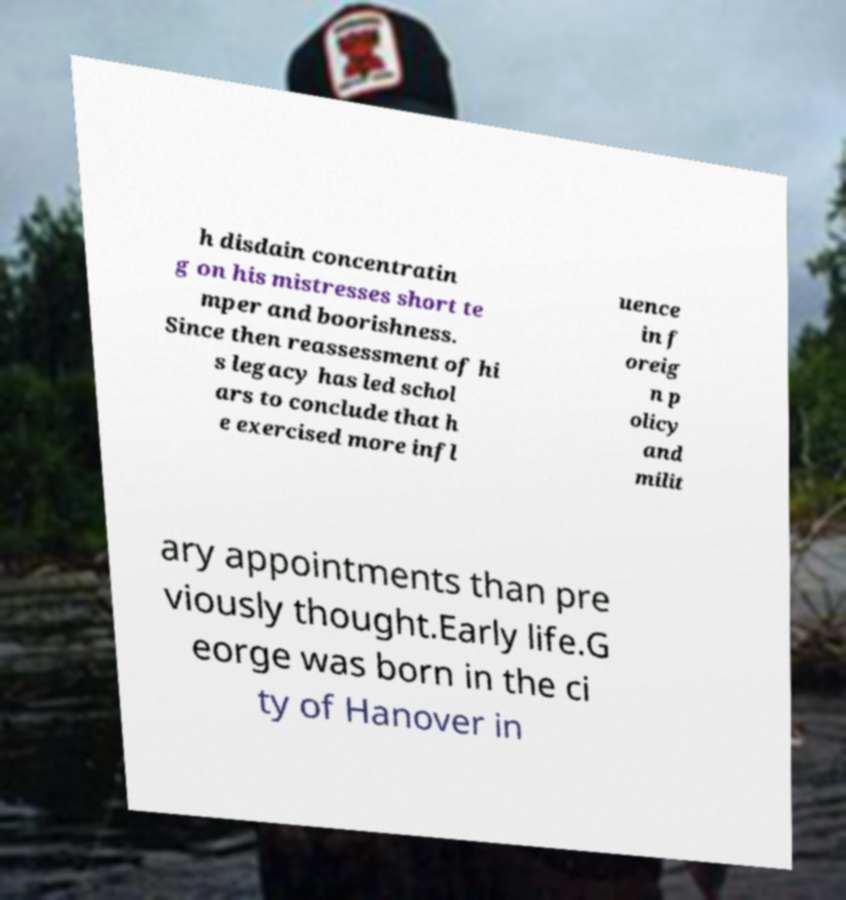Can you accurately transcribe the text from the provided image for me? h disdain concentratin g on his mistresses short te mper and boorishness. Since then reassessment of hi s legacy has led schol ars to conclude that h e exercised more infl uence in f oreig n p olicy and milit ary appointments than pre viously thought.Early life.G eorge was born in the ci ty of Hanover in 